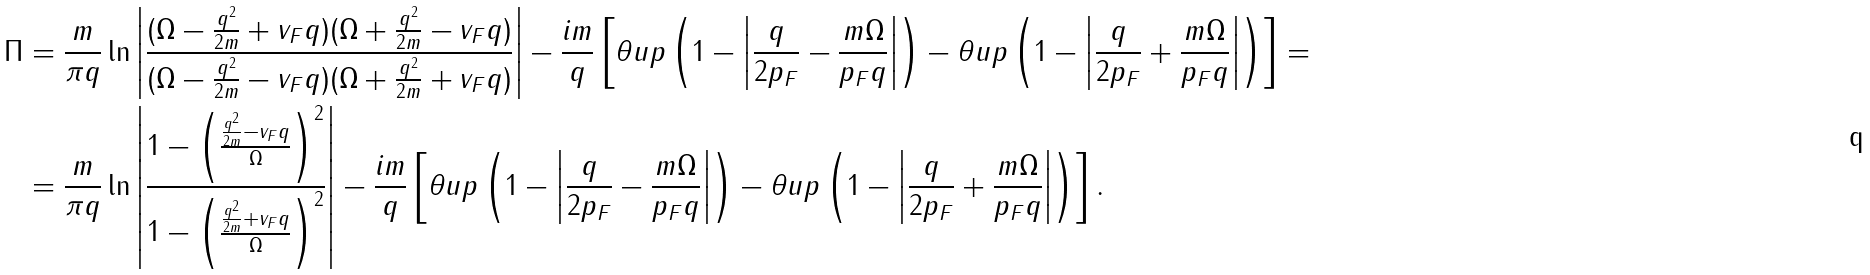Convert formula to latex. <formula><loc_0><loc_0><loc_500><loc_500>\Pi & = \frac { m } { \pi q } \ln \left | \frac { ( \Omega - \frac { q ^ { 2 } } { 2 m } + v _ { F } q ) ( \Omega + \frac { q ^ { 2 } } { 2 m } - v _ { F } q ) } { ( \Omega - \frac { q ^ { 2 } } { 2 m } - v _ { F } q ) ( \Omega + \frac { q ^ { 2 } } { 2 m } + v _ { F } q ) } \right | - \frac { i m } { q } \left [ \theta u p \left ( 1 - \left | \frac { q } { 2 p _ { F } } - \frac { m \Omega } { p _ { F } q } \right | \right ) - \theta u p \left ( 1 - \left | \frac { q } { 2 p _ { F } } + \frac { m \Omega } { p _ { F } q } \right | \right ) \right ] = \\ & = \frac { m } { \pi q } \ln \left | \frac { 1 - \left ( \frac { \frac { q ^ { 2 } } { 2 m } - v _ { F } q } { \Omega } \right ) ^ { 2 } } { 1 - \left ( \frac { \frac { q ^ { 2 } } { 2 m } + v _ { F } q } { \Omega } \right ) ^ { 2 } } \right | - \frac { i m } { q } \left [ \theta u p \left ( 1 - \left | \frac { q } { 2 p _ { F } } - \frac { m \Omega } { p _ { F } q } \right | \right ) - \theta u p \left ( 1 - \left | \frac { q } { 2 p _ { F } } + \frac { m \Omega } { p _ { F } q } \right | \right ) \right ] .</formula> 